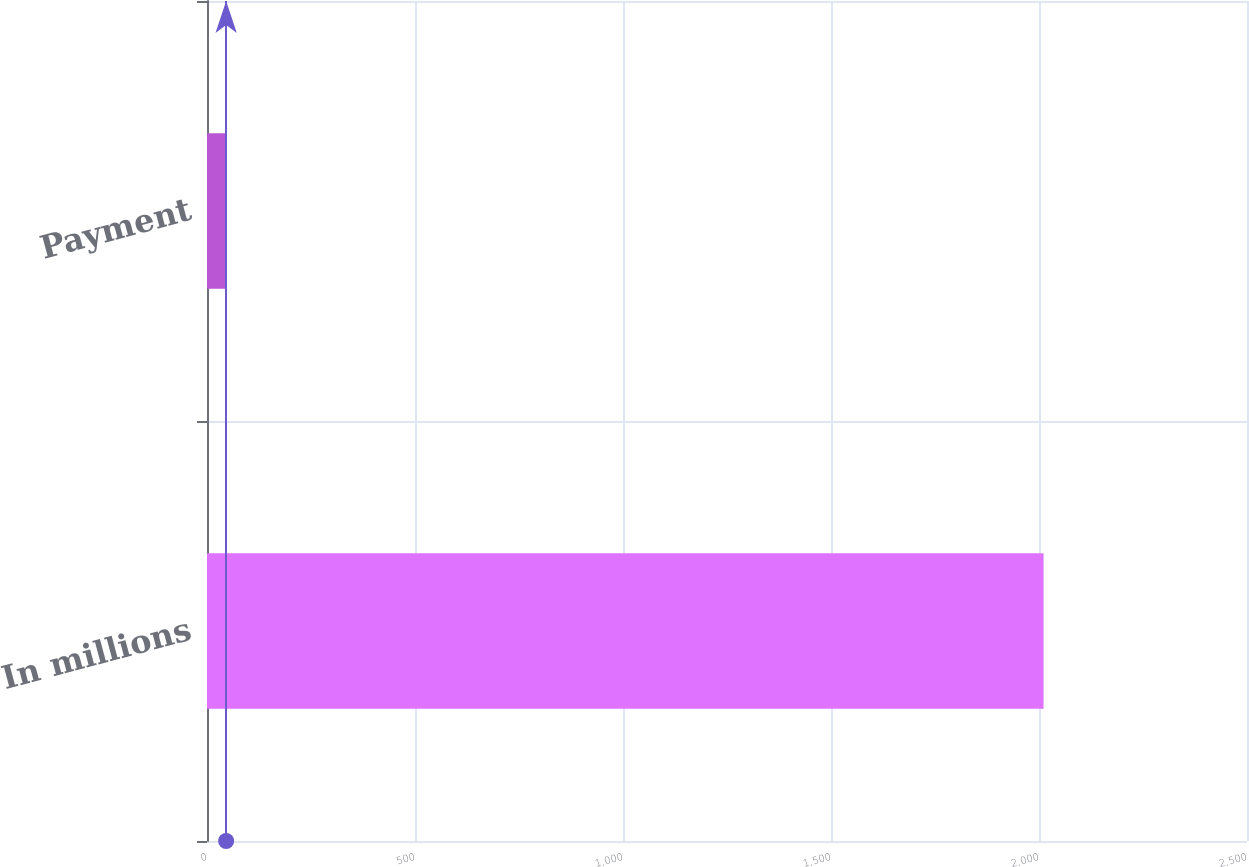<chart> <loc_0><loc_0><loc_500><loc_500><bar_chart><fcel>In millions<fcel>Payment<nl><fcel>2011<fcel>46<nl></chart> 